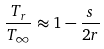Convert formula to latex. <formula><loc_0><loc_0><loc_500><loc_500>\frac { T _ { r } } { T _ { \infty } } \approx 1 - \frac { s } { 2 r }</formula> 